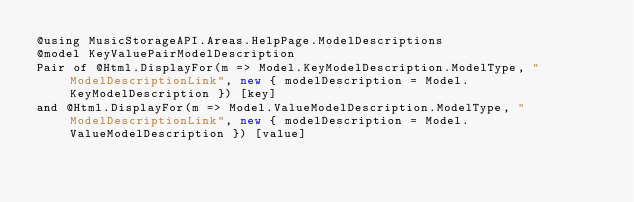Convert code to text. <code><loc_0><loc_0><loc_500><loc_500><_C#_>@using MusicStorageAPI.Areas.HelpPage.ModelDescriptions
@model KeyValuePairModelDescription
Pair of @Html.DisplayFor(m => Model.KeyModelDescription.ModelType, "ModelDescriptionLink", new { modelDescription = Model.KeyModelDescription }) [key]
and @Html.DisplayFor(m => Model.ValueModelDescription.ModelType, "ModelDescriptionLink", new { modelDescription = Model.ValueModelDescription }) [value]</code> 